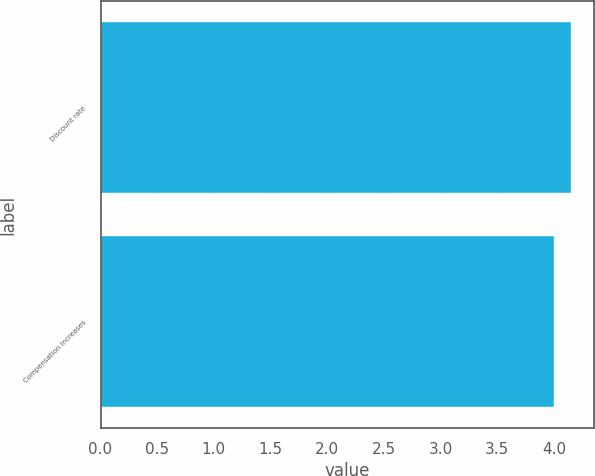Convert chart. <chart><loc_0><loc_0><loc_500><loc_500><bar_chart><fcel>Discount rate<fcel>Compensation increases<nl><fcel>4.15<fcel>4<nl></chart> 